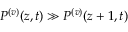Convert formula to latex. <formula><loc_0><loc_0><loc_500><loc_500>P ^ { ( v ) } ( z , t ) \gg P ^ { ( v ) } ( z + 1 , t )</formula> 